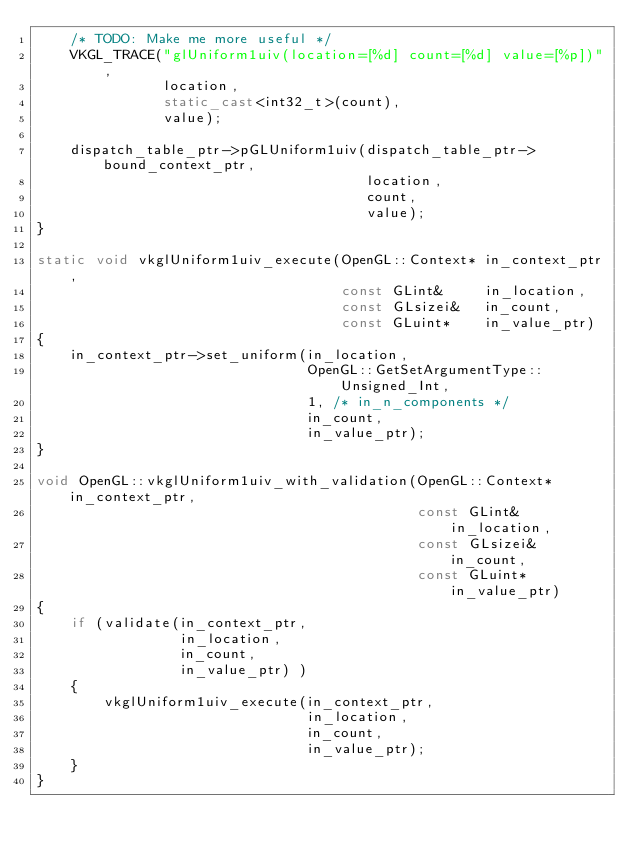Convert code to text. <code><loc_0><loc_0><loc_500><loc_500><_C++_>    /* TODO: Make me more useful */
    VKGL_TRACE("glUniform1uiv(location=[%d] count=[%d] value=[%p])",
               location,
               static_cast<int32_t>(count),
               value);

    dispatch_table_ptr->pGLUniform1uiv(dispatch_table_ptr->bound_context_ptr,
                                       location,
                                       count,
                                       value);
}

static void vkglUniform1uiv_execute(OpenGL::Context* in_context_ptr,
                                    const GLint&     in_location,
                                    const GLsizei&   in_count,
                                    const GLuint*    in_value_ptr)
{
    in_context_ptr->set_uniform(in_location,
                                OpenGL::GetSetArgumentType::Unsigned_Int,
                                1, /* in_n_components */
                                in_count,
                                in_value_ptr);
}

void OpenGL::vkglUniform1uiv_with_validation(OpenGL::Context* in_context_ptr,
                                             const GLint&     in_location,
                                             const GLsizei&   in_count,
                                             const GLuint*    in_value_ptr)
{
    if (validate(in_context_ptr,
                 in_location,
                 in_count,
                 in_value_ptr) )
    {
        vkglUniform1uiv_execute(in_context_ptr,
                                in_location,
                                in_count,
                                in_value_ptr);
    }
}
</code> 